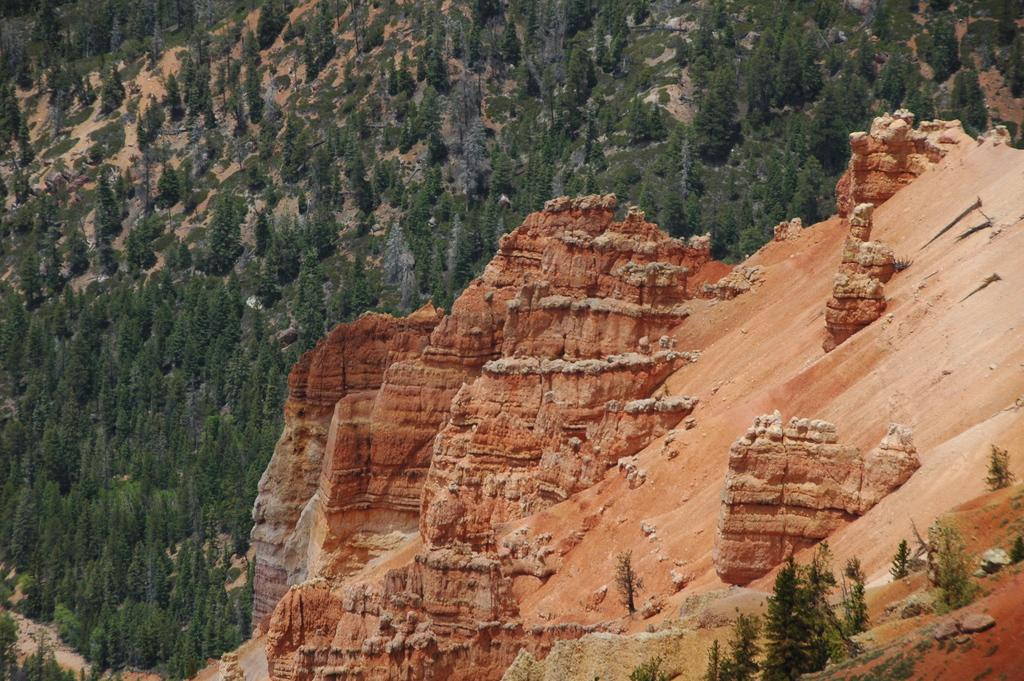What type of landscape feature is visible in the image? There is a hill in the image. What can be seen in the distance behind the hill? There are trees in the background of the image. What objects are located at the right bottom of the image? Stones are present at the right bottom of the image. What type of crayon is being used to draw on the hill in the image? There is no crayon or drawing present in the image; it is a natural landscape scene. 